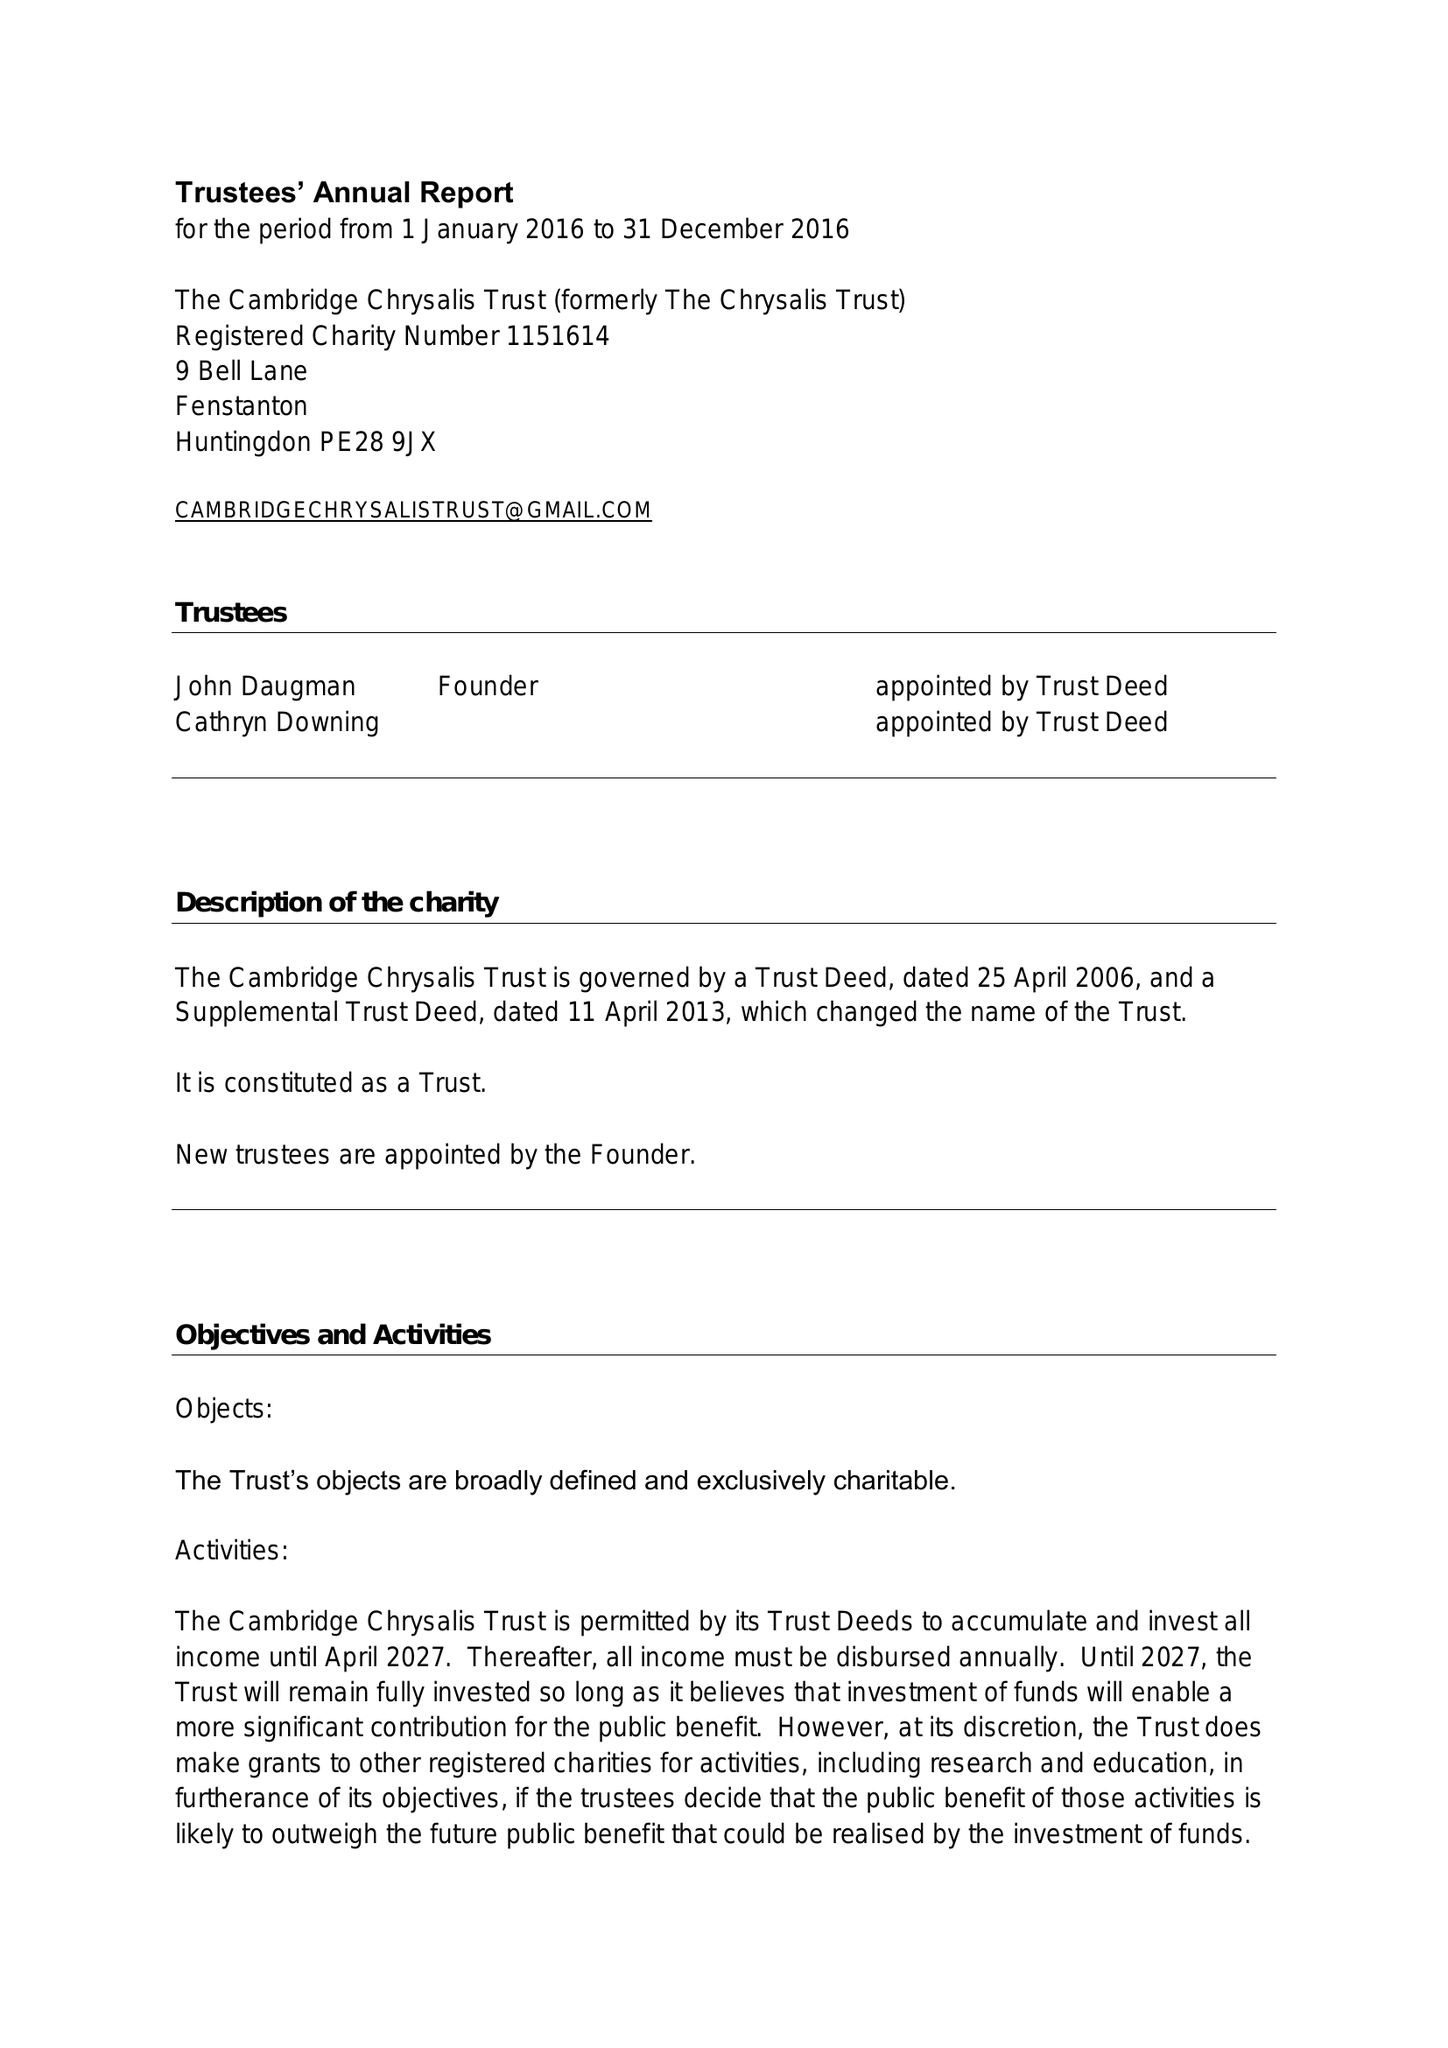What is the value for the charity_name?
Answer the question using a single word or phrase. The Cambridge Chrysalis Trust 